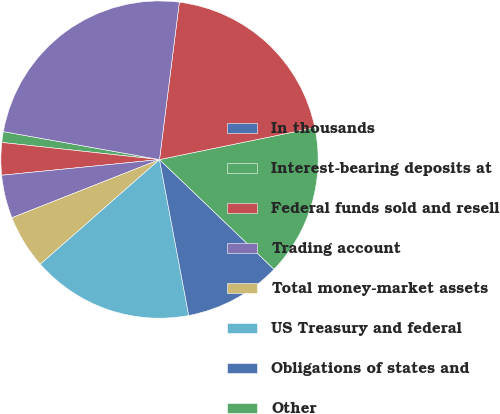Convert chart. <chart><loc_0><loc_0><loc_500><loc_500><pie_chart><fcel>In thousands<fcel>Interest-bearing deposits at<fcel>Federal funds sold and resell<fcel>Trading account<fcel>Total money-market assets<fcel>US Treasury and federal<fcel>Obligations of states and<fcel>Other<fcel>Total investment securities<fcel>Commercial financial leasing<nl><fcel>0.0%<fcel>1.1%<fcel>3.3%<fcel>4.4%<fcel>5.49%<fcel>16.48%<fcel>9.89%<fcel>15.38%<fcel>19.78%<fcel>24.17%<nl></chart> 